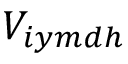<formula> <loc_0><loc_0><loc_500><loc_500>V _ { i y m d h }</formula> 